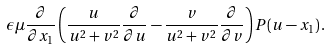Convert formula to latex. <formula><loc_0><loc_0><loc_500><loc_500>\epsilon \mu \frac { \partial } { \partial x _ { 1 } } \left ( \frac { u } { u ^ { 2 } + v ^ { 2 } } \frac { \partial } { \partial u } - \frac { v } { u ^ { 2 } + v ^ { 2 } } \frac { \partial } { \partial v } \right ) P ( u - x _ { 1 } ) \, .</formula> 